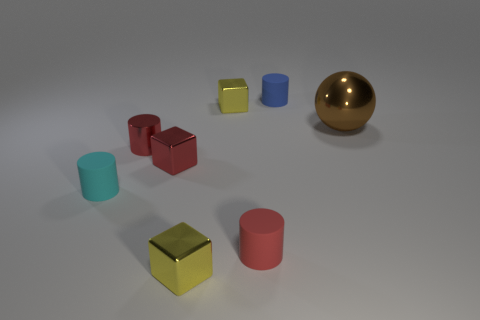Is there any pattern in the sizes of the objects presented? There doesn’t appear to be a strict pattern to the sizes of the objects, but there is some variation. For instance, the two blue cylinders are of different sizes, and the gold sphere is the largest object in the scene. The cubes also vary in size, with the yellow one being the smallest object and the red cube being larger. 